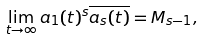<formula> <loc_0><loc_0><loc_500><loc_500>\lim _ { t \rightarrow \infty } a _ { 1 } ( t ) ^ { s } \overline { a _ { s } ( t ) } = M _ { s - 1 } ,</formula> 